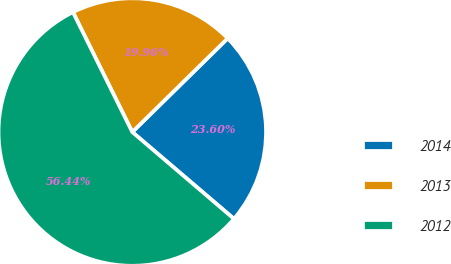Convert chart to OTSL. <chart><loc_0><loc_0><loc_500><loc_500><pie_chart><fcel>2014<fcel>2013<fcel>2012<nl><fcel>23.6%<fcel>19.96%<fcel>56.44%<nl></chart> 